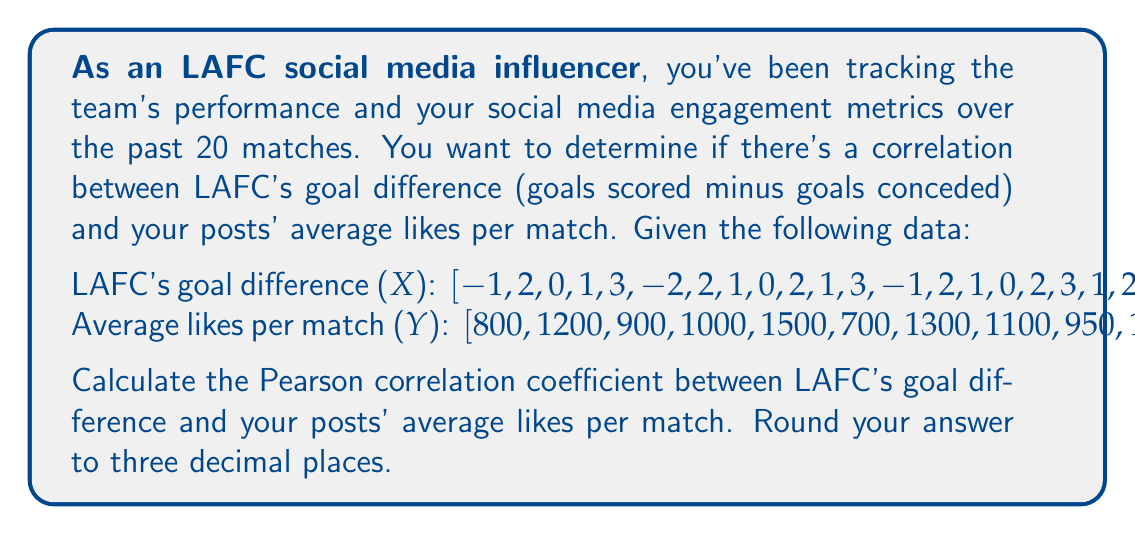Could you help me with this problem? To calculate the Pearson correlation coefficient between LAFC's goal difference (X) and average likes per match (Y), we'll use the following formula:

$$ r = \frac{\sum_{i=1}^{n} (x_i - \bar{x})(y_i - \bar{y})}{\sqrt{\sum_{i=1}^{n} (x_i - \bar{x})^2} \sqrt{\sum_{i=1}^{n} (y_i - \bar{y})^2}} $$

Where:
$r$ is the Pearson correlation coefficient
$x_i$ and $y_i$ are individual values of X and Y
$\bar{x}$ and $\bar{y}$ are the means of X and Y

Step 1: Calculate the means
$\bar{x} = \frac{\sum_{i=1}^{n} x_i}{n} = \frac{22}{20} = 1.1$
$\bar{y} = \frac{\sum_{i=1}^{n} y_i}{n} = \frac{21150}{20} = 1057.5$

Step 2: Calculate $(x_i - \bar{x})$ and $(y_i - \bar{y})$ for each pair of data points

Step 3: Calculate $(x_i - \bar{x})^2$, $(y_i - \bar{y})^2$, and $(x_i - \bar{x})(y_i - \bar{y})$ for each pair

Step 4: Sum up the results from Step 3
$\sum (x_i - \bar{x})^2 = 52.9$
$\sum (y_i - \bar{y})^2 = 1,030,312.5$
$\sum (x_i - \bar{x})(y_i - \bar{y}) = 6,912.5$

Step 5: Apply the formula
$$ r = \frac{6,912.5}{\sqrt{52.9} \sqrt{1,030,312.5}} = \frac{6,912.5}{7,373.37} \approx 0.938 $$

Therefore, the Pearson correlation coefficient rounded to three decimal places is 0.938.
Answer: 0.938 